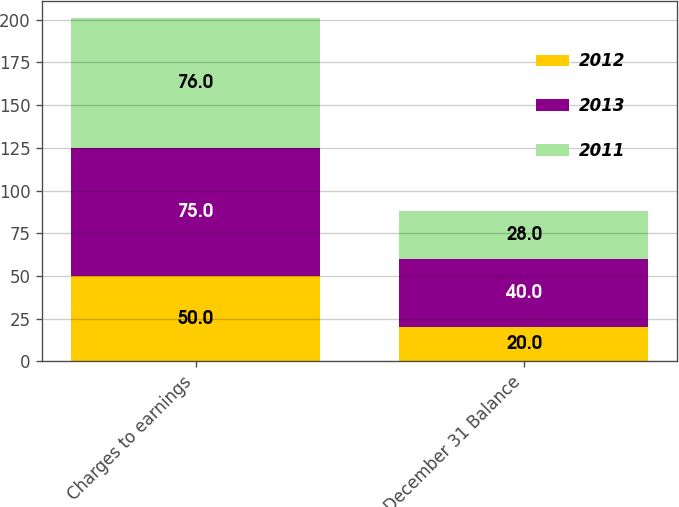Convert chart. <chart><loc_0><loc_0><loc_500><loc_500><stacked_bar_chart><ecel><fcel>Charges to earnings<fcel>December 31 Balance<nl><fcel>2012<fcel>50<fcel>20<nl><fcel>2013<fcel>75<fcel>40<nl><fcel>2011<fcel>76<fcel>28<nl></chart> 